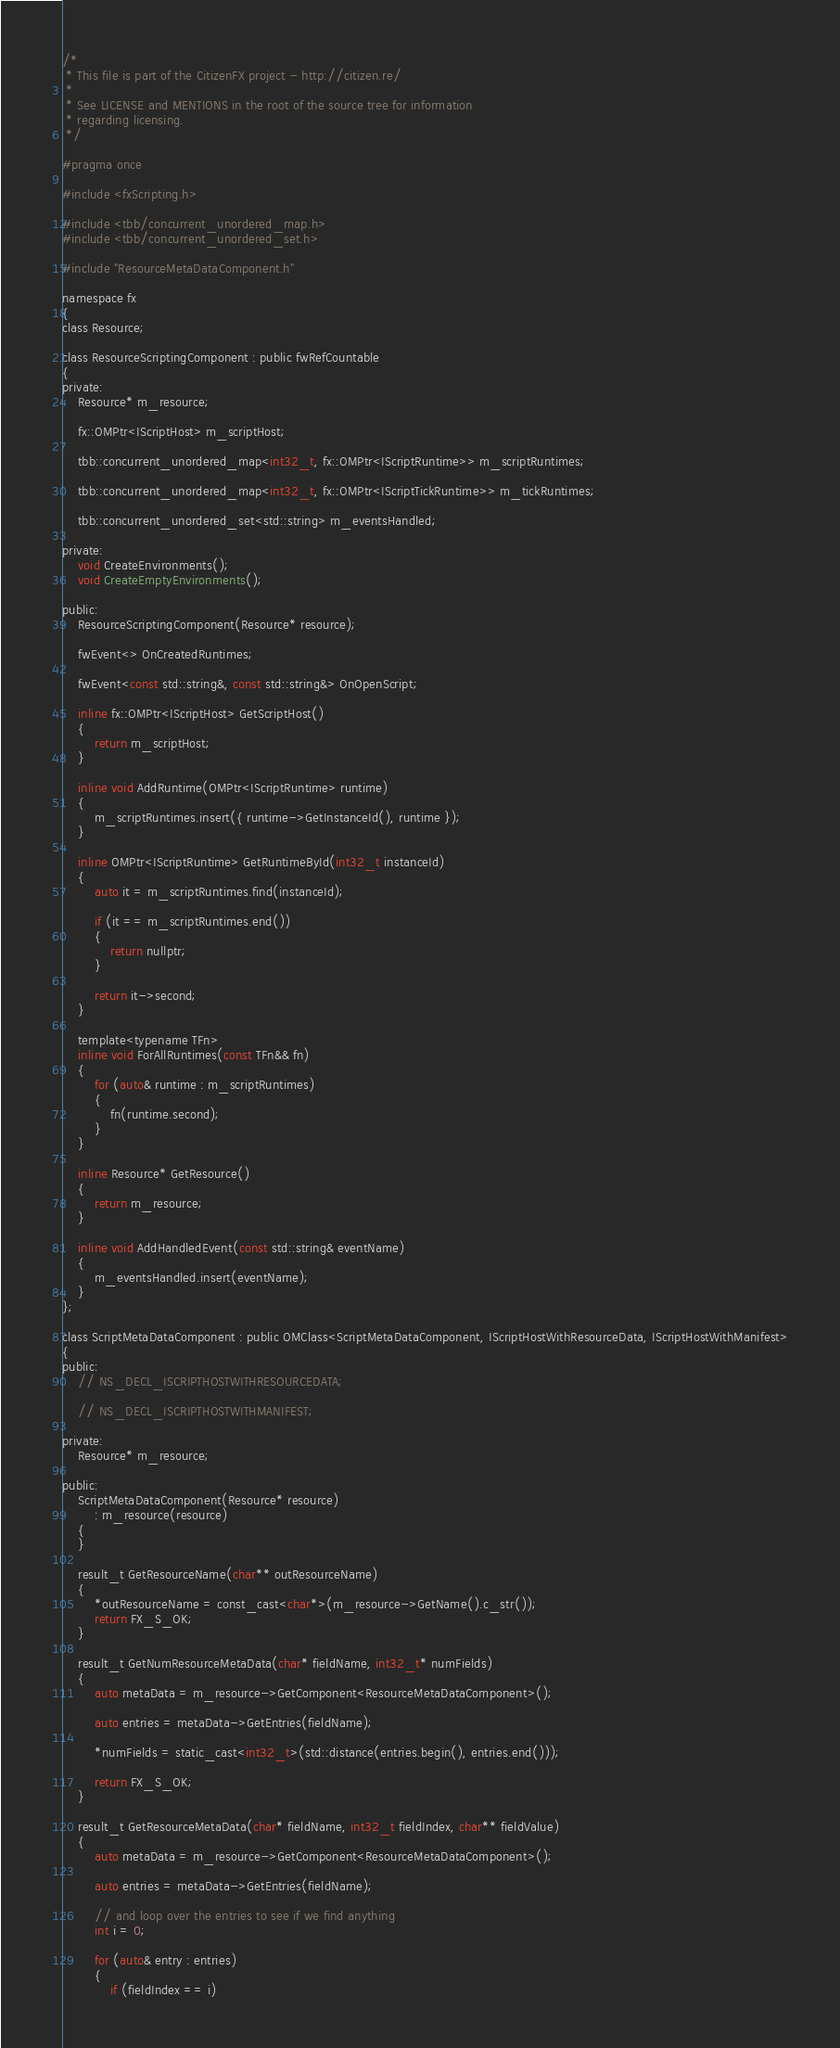<code> <loc_0><loc_0><loc_500><loc_500><_C_>/*
 * This file is part of the CitizenFX project - http://citizen.re/
 *
 * See LICENSE and MENTIONS in the root of the source tree for information
 * regarding licensing.
 */

#pragma once

#include <fxScripting.h>

#include <tbb/concurrent_unordered_map.h>
#include <tbb/concurrent_unordered_set.h>

#include "ResourceMetaDataComponent.h"

namespace fx
{
class Resource;

class ResourceScriptingComponent : public fwRefCountable
{
private:
	Resource* m_resource;

	fx::OMPtr<IScriptHost> m_scriptHost;

	tbb::concurrent_unordered_map<int32_t, fx::OMPtr<IScriptRuntime>> m_scriptRuntimes;

	tbb::concurrent_unordered_map<int32_t, fx::OMPtr<IScriptTickRuntime>> m_tickRuntimes;

	tbb::concurrent_unordered_set<std::string> m_eventsHandled;

private:
	void CreateEnvironments();
	void CreateEmptyEnvironments();

public:
	ResourceScriptingComponent(Resource* resource);

	fwEvent<> OnCreatedRuntimes;

	fwEvent<const std::string&, const std::string&> OnOpenScript;

	inline fx::OMPtr<IScriptHost> GetScriptHost()
	{
		return m_scriptHost;
	}

	inline void AddRuntime(OMPtr<IScriptRuntime> runtime)
	{
		m_scriptRuntimes.insert({ runtime->GetInstanceId(), runtime });
	}

	inline OMPtr<IScriptRuntime> GetRuntimeById(int32_t instanceId)
	{
		auto it = m_scriptRuntimes.find(instanceId);

		if (it == m_scriptRuntimes.end())
		{
			return nullptr;
		}

		return it->second;
	}

	template<typename TFn>
	inline void ForAllRuntimes(const TFn&& fn)
	{
		for (auto& runtime : m_scriptRuntimes)
		{
			fn(runtime.second);
		}
	}

	inline Resource* GetResource()
	{
		return m_resource;
	}

	inline void AddHandledEvent(const std::string& eventName)
	{
		m_eventsHandled.insert(eventName);
	}
};

class ScriptMetaDataComponent : public OMClass<ScriptMetaDataComponent, IScriptHostWithResourceData, IScriptHostWithManifest>
{
public:
	// NS_DECL_ISCRIPTHOSTWITHRESOURCEDATA;

	// NS_DECL_ISCRIPTHOSTWITHMANIFEST;

private:
	Resource* m_resource;

public:
	ScriptMetaDataComponent(Resource* resource)
		: m_resource(resource)
	{
	}

	result_t GetResourceName(char** outResourceName)
	{
		*outResourceName = const_cast<char*>(m_resource->GetName().c_str());
		return FX_S_OK;
	}

	result_t GetNumResourceMetaData(char* fieldName, int32_t* numFields)
	{
		auto metaData = m_resource->GetComponent<ResourceMetaDataComponent>();

		auto entries = metaData->GetEntries(fieldName);

		*numFields = static_cast<int32_t>(std::distance(entries.begin(), entries.end()));

		return FX_S_OK;
	}

	result_t GetResourceMetaData(char* fieldName, int32_t fieldIndex, char** fieldValue)
	{
		auto metaData = m_resource->GetComponent<ResourceMetaDataComponent>();

		auto entries = metaData->GetEntries(fieldName);

		// and loop over the entries to see if we find anything
		int i = 0;

		for (auto& entry : entries)
		{
			if (fieldIndex == i)</code> 